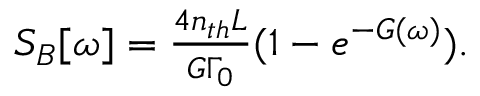<formula> <loc_0><loc_0><loc_500><loc_500>\begin{array} { r } { S _ { B } [ \omega ] = \frac { 4 n _ { t h } L } { G \Gamma _ { 0 } } ( 1 - e ^ { - G ( \omega ) } ) . } \end{array}</formula> 